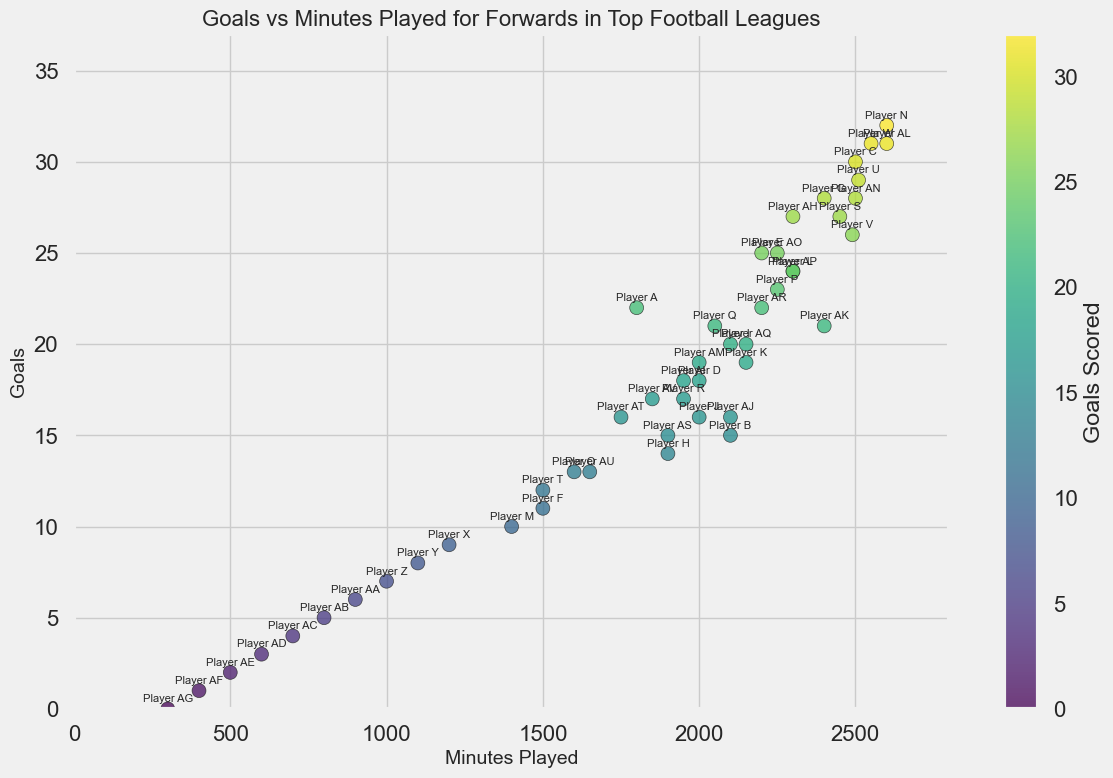What is the range of minutes played by the forwards? To find the range, we subtract the minimum value of minutes played from the maximum value in the figure. The minimum value is 300 (Player AG) and the maximum value is 2600 (Players N and AL). So, the range is 2600 - 300.
Answer: 2300 minutes Which player scored the most goals and how many goals did they score? Looking at the scatter plot, we locate the highest point on the y-axis that represents goals. Player N has the highest number of goals with 32 goals.
Answer: Player N, 32 goals How many players scored exactly 24 goals? By identifying points at the 24-goal level along the y-axis, we see Players L and AP.
Answer: 2 players Across all players, what is the median number of goals? To determine the median, we need to sort the number of goals and find the middle value. With 48 players, the median is the average of the 24th and 25th values in the sorted list.
Answer: 18 goals Who has the highest goal-per-minute ratio among the players? For each player, we need to compute the ratio of goals to minutes played. Player W has 31 goals in 2550 minutes, and Player N has 32 goals in 2600 minutes. First, calculate for each player, then compare. Player W's ratio is 31/2550 ≈ 0.0122, while Player N's ratio is 32/2600 ≈ 0.0123. The highest ratio belongs to whoever has the highest calculated value
Answer: Player N Who played the least minutes but scored more than 15 goals? Checking the x-axis for the lower range of minutes played and those players who scored more than 15 goals, Player AT (16 goals, 1750 minutes) played the least minutes.
Answer: Player AT Do more players have a goal count above or below 15 goals? Count the number of players with more than 15 goals and those with 15 or fewer goals by observing their positions above and below the 15-goal mark on the y-axis.
Answer: More players above 15 goals How many players scored less than 10 goals and played more than 1500 minutes? Check for players below the 10-goal mark on the y-axis and to the right of the 1500-minute mark on the x-axis. There are none.
Answer: 0 players Which player had the highest discrepancy between goals scored and minutes played? To determine the highest discrepancy, look for a high goals-to-minutes ratio or significant vertical distance above the main cluster. This can be approximated visually by finding outliers far above the clustered data points. Player AG scored 0 goals in 300 minutes showing a minimal discrepancy.
Answer: Player AG in minutes but for the highest goals, it would require more detail calculation What is the average number of goals scored by players who played between 2000 and 2500 minutes? Identify players within the minute range and compute the average by summing their goals and dividing by the number of such players. Players D, B, J, AI, AJ, AM, AH, AK, AR, AO, P, V, AN, S lie within this range. Summing the goals: 18 + 15+ 16+18 + 16 + 19 + 27 + 21 + 22 + 25 + 23 + 26 + 28 + 27 = 351 divided by the number of players (14).
Answer: 25.07 goals 